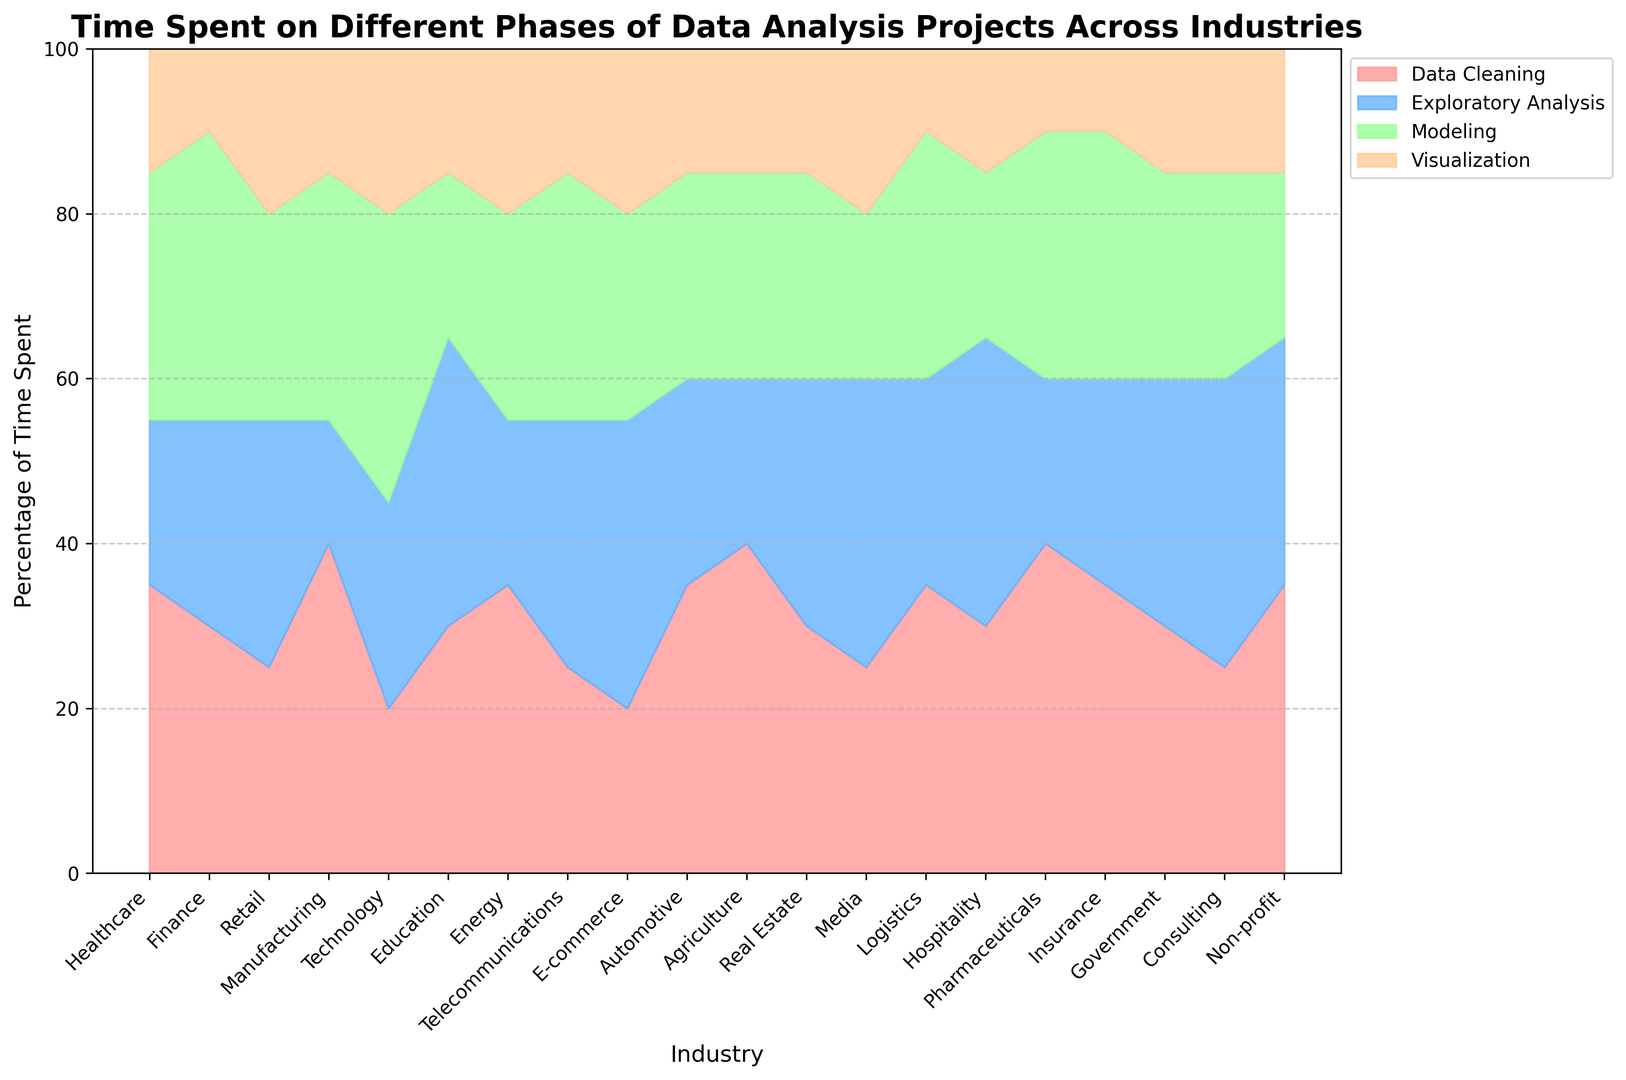Which industry spends the most time on data cleaning? Look at the 'Data Cleaning' segment for each industry and find the highest value. The highest value of 40% is present in the Manufacturing, Agriculture, and Pharmaceuticals industries.
Answer: Manufacturing, Agriculture, Pharmaceuticals Which industries spend 30% or more time on modeling? Look at the 'Modeling' segment and identify industries with values of 30% or more. These are Finance, Healthcare, Manufacturing, Telecommunications, Pharmaceuticals, Logistics, and Insurance.
Answer: Finance, Healthcare, Manufacturing, Telecommunications, Pharmaceuticals, Logistics, Insurance Which phase takes the least amount of time in the Technology industry? For the Technology industry, compare the heights of the four phases. 'Data Cleaning' is 20%, 'Exploratory Analysis' is 25%, 'Modeling' is 35%, and 'Visualization' is 20%. The least amount of time is spent on the Data Cleaning and Visualization phases which both have 20%.
Answer: Data Cleaning, Visualization How much more time does Government spend on data cleaning compared to Technology? Government spends 30% on Data Cleaning, whereas Technology spends 20% on Data Cleaning. The difference is 30% - 20% = 10%.
Answer: 10% Which industry has the smallest proportion of time spent on data cleaning relative to its total? Look at the 'Data Cleaning' segment and identify the smallest value. The smallest value is 20% for Technology and E-commerce.
Answer: Technology, E-commerce What is the combined time spent on exploratory analysis and visualization in Retail? In Retail, Exploratory Analysis is 30% and Visualization is 20%. Summing these values, 30% + 20% = 50%.
Answer: 50% Which industry has the greatest spread in time spent across all phases? Calculate the difference between the maximum and minimum phase times for each industry. The greatest difference is observed in Healthcare, with a spread of 35% - 15% = 20%.
Answer: Healthcare Is the time spent on different phases relatively balanced in the Finance industry? In Finance, the times spent are 30% for Data Cleaning, 25% for Exploratory Analysis, 35% for Modeling, and 10% for Visualization. Compare these values.
Answer: Not balanced, largest spread is 25% Which industry spends the most combined time on exploratory analysis and modeling? Sum the 'Exploratory Analysis' and 'Modeling' times for each industry and find the maximum. The combined time is 35% + 35% = 70% for Technology.
Answer: Technology 